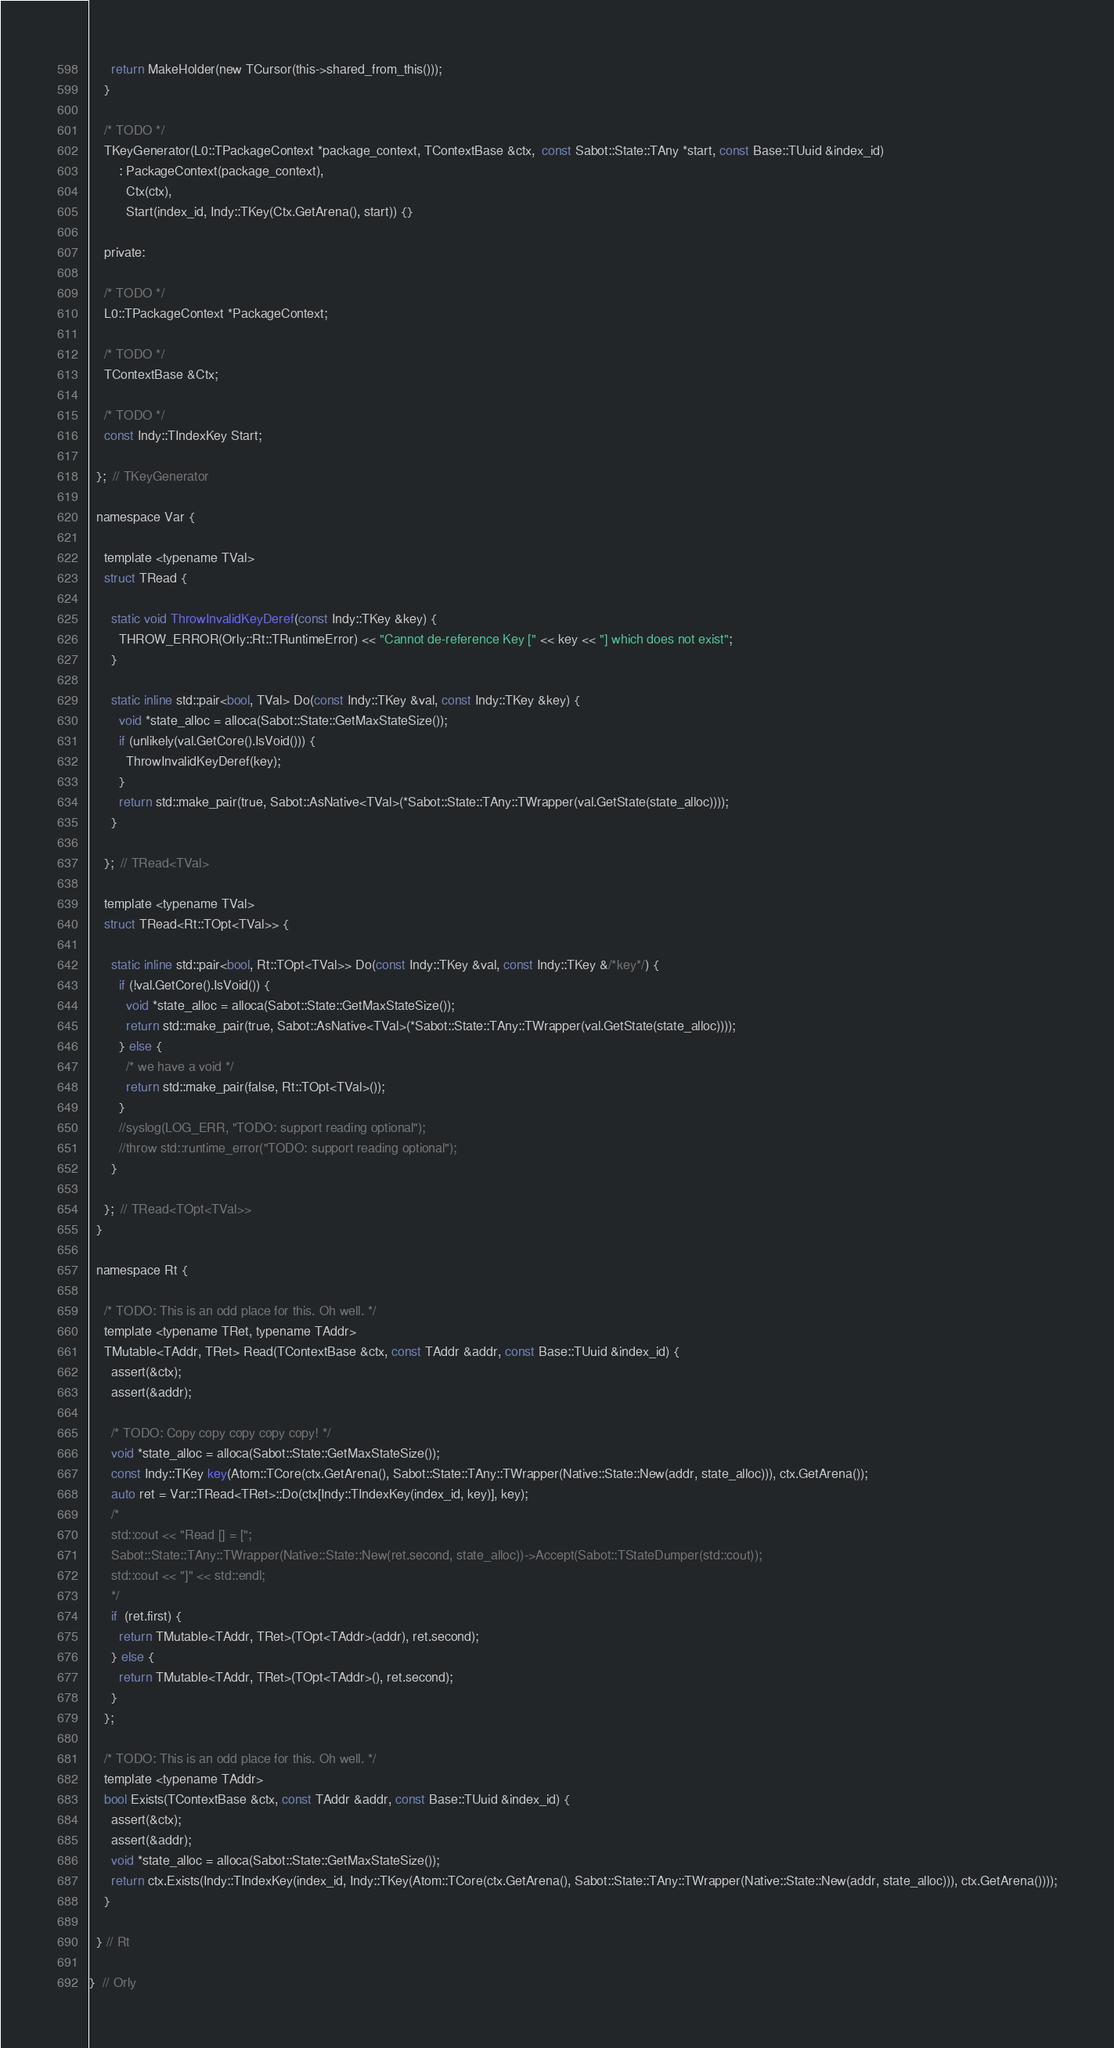<code> <loc_0><loc_0><loc_500><loc_500><_C_>      return MakeHolder(new TCursor(this->shared_from_this()));
    }

    /* TODO */
    TKeyGenerator(L0::TPackageContext *package_context, TContextBase &ctx,  const Sabot::State::TAny *start, const Base::TUuid &index_id)
        : PackageContext(package_context),
          Ctx(ctx),
          Start(index_id, Indy::TKey(Ctx.GetArena(), start)) {}

    private:

    /* TODO */
    L0::TPackageContext *PackageContext;

    /* TODO */
    TContextBase &Ctx;

    /* TODO */
    const Indy::TIndexKey Start;

  };  // TKeyGenerator

  namespace Var {

    template <typename TVal>
    struct TRead {

      static void ThrowInvalidKeyDeref(const Indy::TKey &key) {
        THROW_ERROR(Orly::Rt::TRuntimeError) << "Cannot de-reference Key [" << key << "] which does not exist";
      }

      static inline std::pair<bool, TVal> Do(const Indy::TKey &val, const Indy::TKey &key) {
        void *state_alloc = alloca(Sabot::State::GetMaxStateSize());
        if (unlikely(val.GetCore().IsVoid())) {
          ThrowInvalidKeyDeref(key);
        }
        return std::make_pair(true, Sabot::AsNative<TVal>(*Sabot::State::TAny::TWrapper(val.GetState(state_alloc))));
      }

    };  // TRead<TVal>

    template <typename TVal>
    struct TRead<Rt::TOpt<TVal>> {

      static inline std::pair<bool, Rt::TOpt<TVal>> Do(const Indy::TKey &val, const Indy::TKey &/*key*/) {
        if (!val.GetCore().IsVoid()) {
          void *state_alloc = alloca(Sabot::State::GetMaxStateSize());
          return std::make_pair(true, Sabot::AsNative<TVal>(*Sabot::State::TAny::TWrapper(val.GetState(state_alloc))));
        } else {
          /* we have a void */
          return std::make_pair(false, Rt::TOpt<TVal>());
        }
        //syslog(LOG_ERR, "TODO: support reading optional");
        //throw std::runtime_error("TODO: support reading optional");
      }

    };  // TRead<TOpt<TVal>>
  }

  namespace Rt {

    /* TODO: This is an odd place for this. Oh well. */
    template <typename TRet, typename TAddr>
    TMutable<TAddr, TRet> Read(TContextBase &ctx, const TAddr &addr, const Base::TUuid &index_id) {
      assert(&ctx);
      assert(&addr);

      /* TODO: Copy copy copy copy copy! */
      void *state_alloc = alloca(Sabot::State::GetMaxStateSize());
      const Indy::TKey key(Atom::TCore(ctx.GetArena(), Sabot::State::TAny::TWrapper(Native::State::New(addr, state_alloc))), ctx.GetArena());
      auto ret = Var::TRead<TRet>::Do(ctx[Indy::TIndexKey(index_id, key)], key);
      /*
      std::cout << "Read [] = [";
      Sabot::State::TAny::TWrapper(Native::State::New(ret.second, state_alloc))->Accept(Sabot::TStateDumper(std::cout));
      std::cout << "]" << std::endl;
      */
      if  (ret.first) {
        return TMutable<TAddr, TRet>(TOpt<TAddr>(addr), ret.second);
      } else {
        return TMutable<TAddr, TRet>(TOpt<TAddr>(), ret.second);
      }
    };

    /* TODO: This is an odd place for this. Oh well. */
    template <typename TAddr>
    bool Exists(TContextBase &ctx, const TAddr &addr, const Base::TUuid &index_id) {
      assert(&ctx);
      assert(&addr);
      void *state_alloc = alloca(Sabot::State::GetMaxStateSize());
      return ctx.Exists(Indy::TIndexKey(index_id, Indy::TKey(Atom::TCore(ctx.GetArena(), Sabot::State::TAny::TWrapper(Native::State::New(addr, state_alloc))), ctx.GetArena())));
    }

  } // Rt

}  // Orly
</code> 